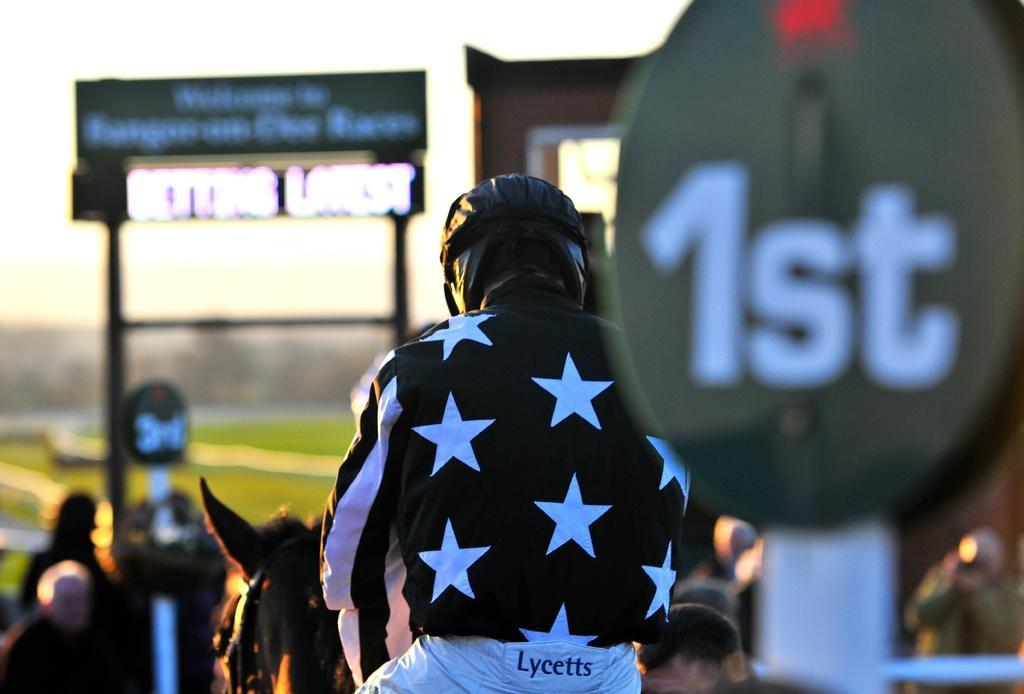Please provide a concise description of this image. In this picture we can see group of people, in the middle of the image we can see a person is seated on the horse, and the person wore a helmet, on the right side of the image we can see a hoarding. 